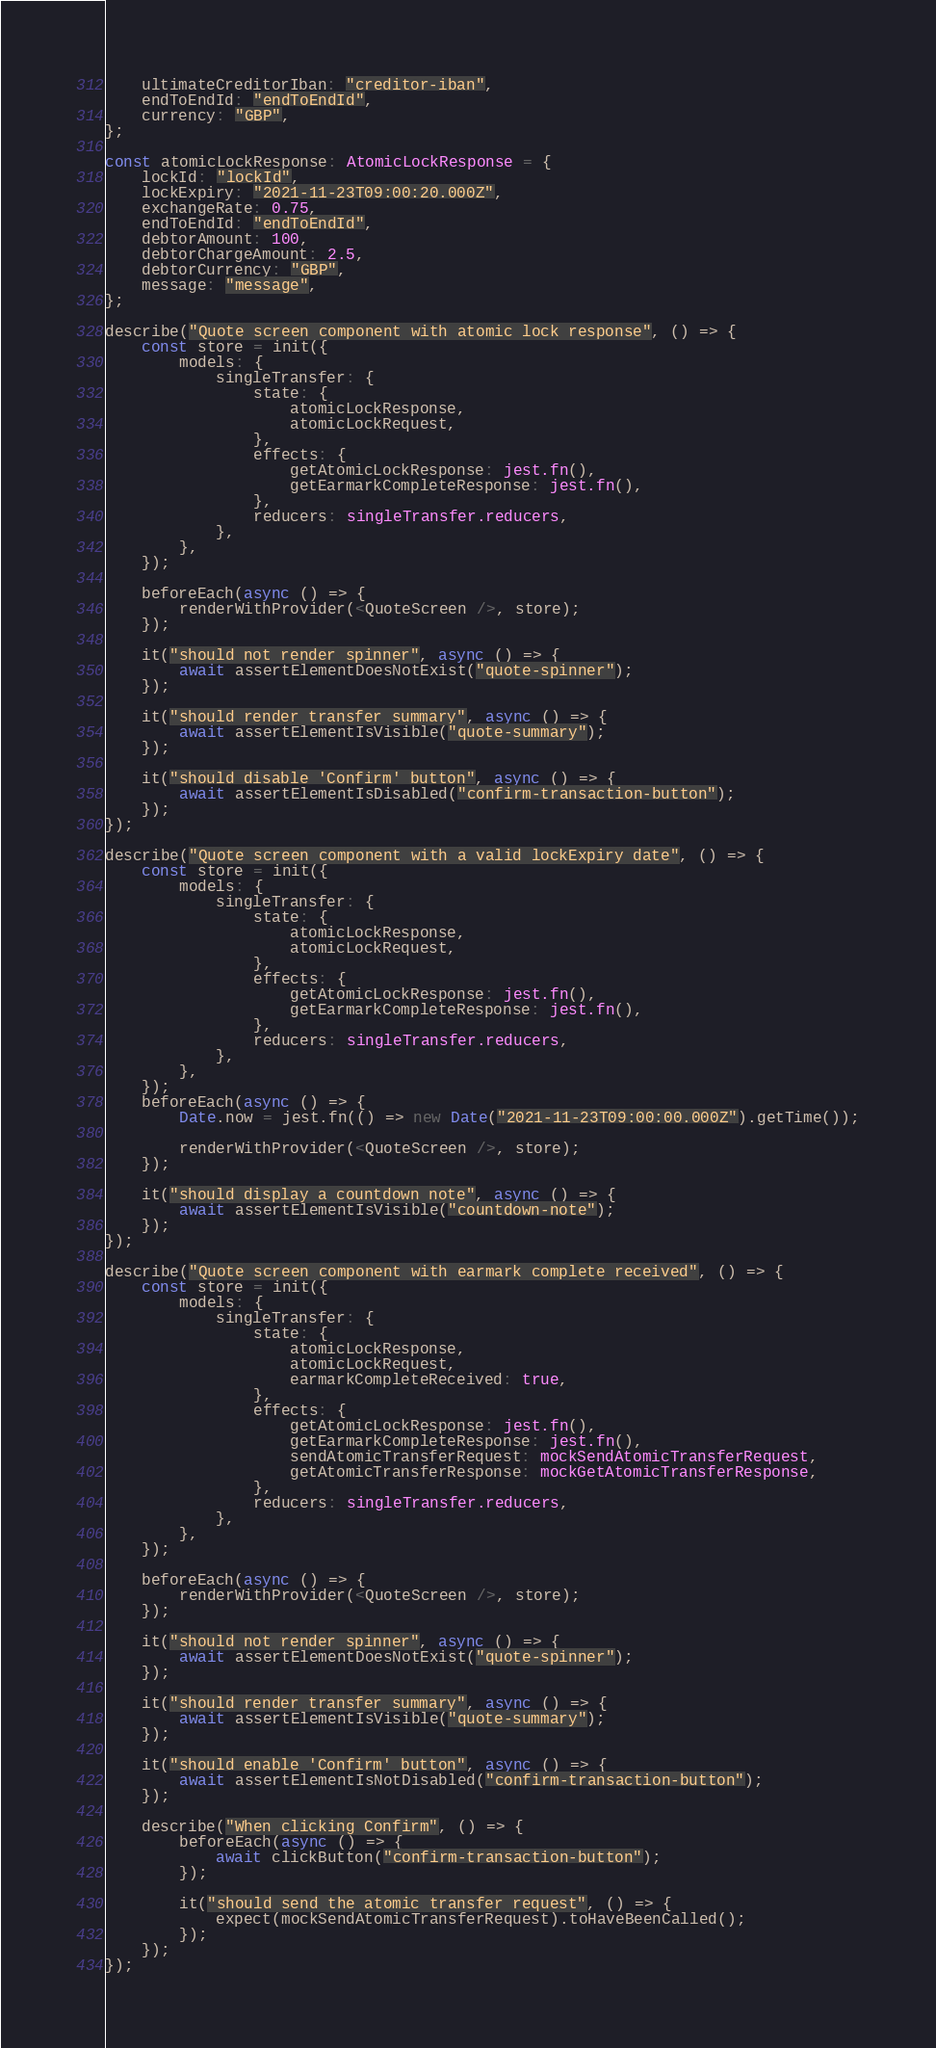Convert code to text. <code><loc_0><loc_0><loc_500><loc_500><_TypeScript_>	ultimateCreditorIban: "creditor-iban",
	endToEndId: "endToEndId",
	currency: "GBP",
};

const atomicLockResponse: AtomicLockResponse = {
	lockId: "lockId",
	lockExpiry: "2021-11-23T09:00:20.000Z",
	exchangeRate: 0.75,
	endToEndId: "endToEndId",
	debtorAmount: 100,
	debtorChargeAmount: 2.5,
	debtorCurrency: "GBP",
	message: "message",
};

describe("Quote screen component with atomic lock response", () => {
	const store = init({
		models: {
			singleTransfer: {
				state: {
					atomicLockResponse,
					atomicLockRequest,
				},
				effects: {
					getAtomicLockResponse: jest.fn(),
					getEarmarkCompleteResponse: jest.fn(),
				},
				reducers: singleTransfer.reducers,
			},
		},
	});

	beforeEach(async () => {
		renderWithProvider(<QuoteScreen />, store);
	});

	it("should not render spinner", async () => {
		await assertElementDoesNotExist("quote-spinner");
	});

	it("should render transfer summary", async () => {
		await assertElementIsVisible("quote-summary");
	});

	it("should disable 'Confirm' button", async () => {
		await assertElementIsDisabled("confirm-transaction-button");
	});
});

describe("Quote screen component with a valid lockExpiry date", () => {
	const store = init({
		models: {
			singleTransfer: {
				state: {
					atomicLockResponse,
					atomicLockRequest,
				},
				effects: {
					getAtomicLockResponse: jest.fn(),
					getEarmarkCompleteResponse: jest.fn(),
				},
				reducers: singleTransfer.reducers,
			},
		},
	});
	beforeEach(async () => {
		Date.now = jest.fn(() => new Date("2021-11-23T09:00:00.000Z").getTime());

		renderWithProvider(<QuoteScreen />, store);
	});

	it("should display a countdown note", async () => {
		await assertElementIsVisible("countdown-note");
	});
});

describe("Quote screen component with earmark complete received", () => {
	const store = init({
		models: {
			singleTransfer: {
				state: {
					atomicLockResponse,
					atomicLockRequest,
					earmarkCompleteReceived: true,
				},
				effects: {
					getAtomicLockResponse: jest.fn(),
					getEarmarkCompleteResponse: jest.fn(),
					sendAtomicTransferRequest: mockSendAtomicTransferRequest,
					getAtomicTransferResponse: mockGetAtomicTransferResponse,
				},
				reducers: singleTransfer.reducers,
			},
		},
	});

	beforeEach(async () => {
		renderWithProvider(<QuoteScreen />, store);
	});

	it("should not render spinner", async () => {
		await assertElementDoesNotExist("quote-spinner");
	});

	it("should render transfer summary", async () => {
		await assertElementIsVisible("quote-summary");
	});

	it("should enable 'Confirm' button", async () => {
		await assertElementIsNotDisabled("confirm-transaction-button");
	});

	describe("When clicking Confirm", () => {
		beforeEach(async () => {
			await clickButton("confirm-transaction-button");
		});

		it("should send the atomic transfer request", () => {
			expect(mockSendAtomicTransferRequest).toHaveBeenCalled();
		});
	});
});
</code> 